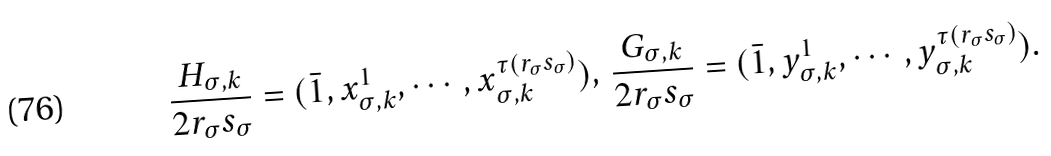<formula> <loc_0><loc_0><loc_500><loc_500>\frac { H _ { \sigma , k } } { 2 r _ { \sigma } s _ { \sigma } } = ( \bar { 1 } , x _ { \sigma , k } ^ { 1 } , \cdots , x _ { \sigma , k } ^ { \tau ( r _ { \sigma } s _ { \sigma } ) } ) , \, \frac { G _ { \sigma , k } } { 2 r _ { \sigma } s _ { \sigma } } = ( \bar { 1 } , y _ { \sigma , k } ^ { 1 } , \cdots , y _ { \sigma , k } ^ { \tau ( r _ { \sigma } s _ { \sigma } ) } ) .</formula> 